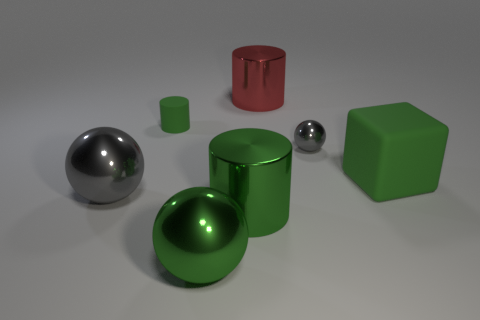Subtract 1 cylinders. How many cylinders are left? 2 Add 3 large red objects. How many objects exist? 10 Subtract all blocks. How many objects are left? 6 Add 4 large red metallic cylinders. How many large red metallic cylinders exist? 5 Subtract 0 gray cubes. How many objects are left? 7 Subtract all big purple shiny cylinders. Subtract all gray spheres. How many objects are left? 5 Add 7 big green rubber things. How many big green rubber things are left? 8 